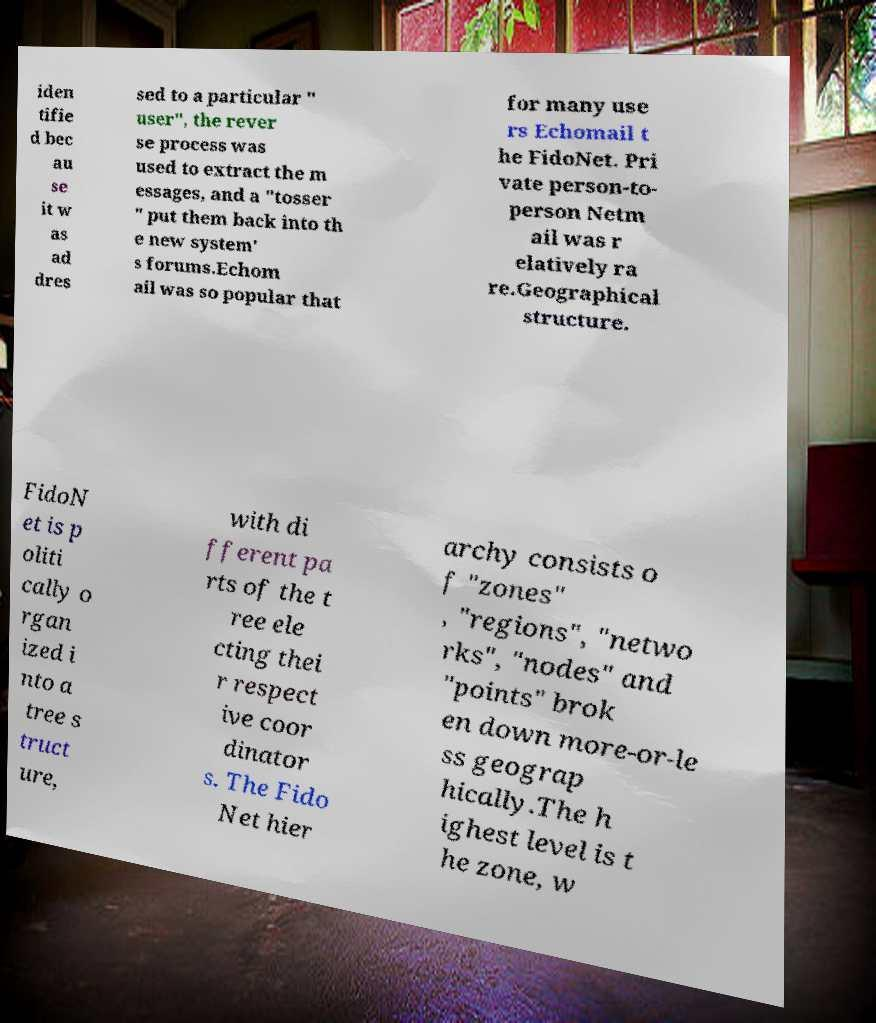There's text embedded in this image that I need extracted. Can you transcribe it verbatim? iden tifie d bec au se it w as ad dres sed to a particular " user", the rever se process was used to extract the m essages, and a "tosser " put them back into th e new system' s forums.Echom ail was so popular that for many use rs Echomail t he FidoNet. Pri vate person-to- person Netm ail was r elatively ra re.Geographical structure. FidoN et is p oliti cally o rgan ized i nto a tree s truct ure, with di fferent pa rts of the t ree ele cting thei r respect ive coor dinator s. The Fido Net hier archy consists o f "zones" , "regions", "netwo rks", "nodes" and "points" brok en down more-or-le ss geograp hically.The h ighest level is t he zone, w 